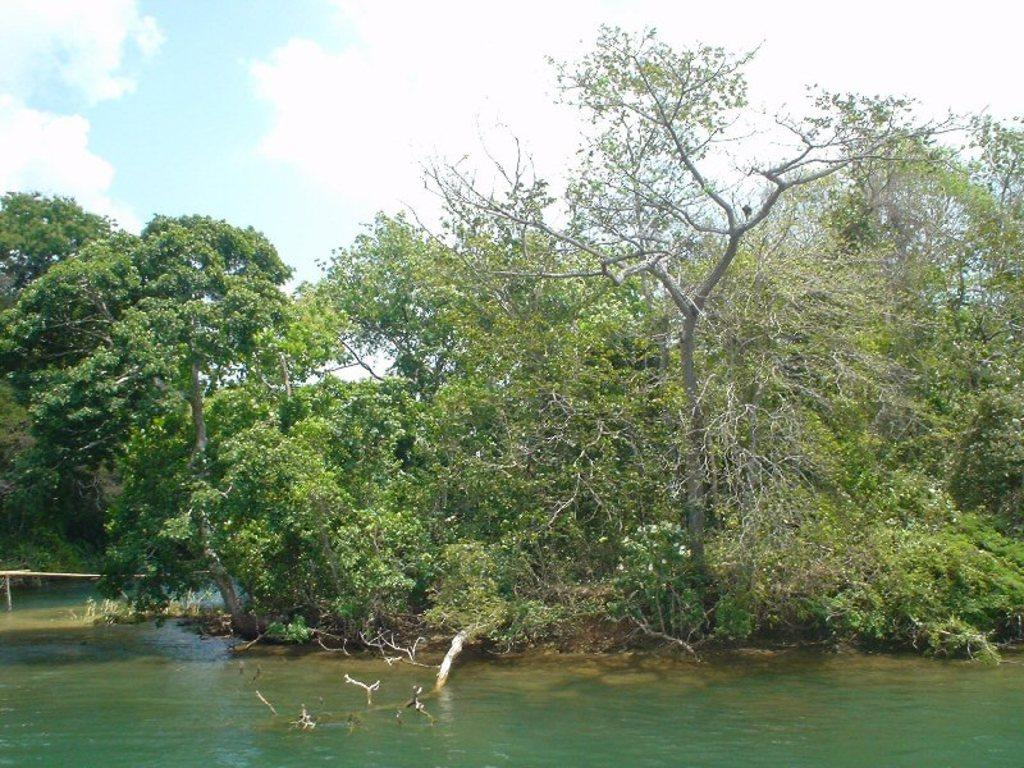What is present in the image that is not solid? There is water visible in the image. What type of vegetation can be seen in the image? There are trees in the image. What is the color of the trees in the image? The trees are green in color. What can be seen in the background of the image? The sky is visible in the background of the image. What type of floor can be seen in the image? There is no floor present in the image; it features water, trees, and a sky background. 